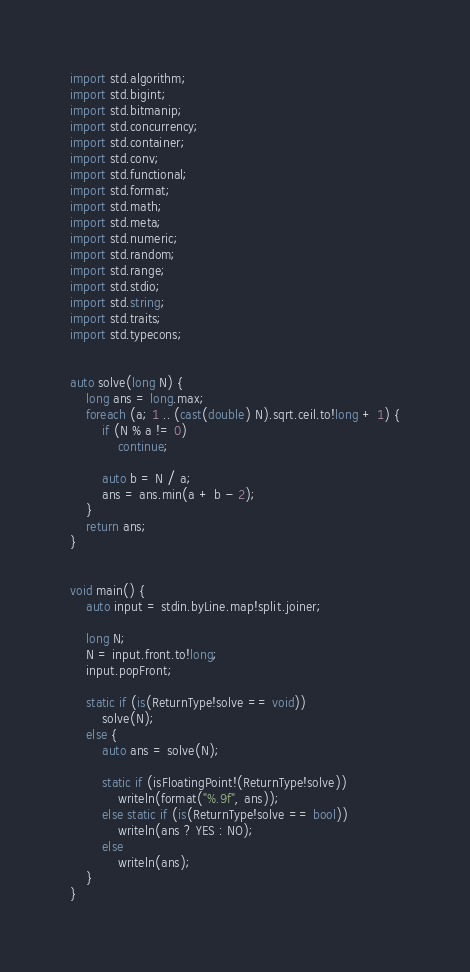Convert code to text. <code><loc_0><loc_0><loc_500><loc_500><_D_>import std.algorithm;
import std.bigint;
import std.bitmanip;
import std.concurrency;
import std.container;
import std.conv;
import std.functional;
import std.format;
import std.math;
import std.meta;
import std.numeric;
import std.random;
import std.range;
import std.stdio;
import std.string;
import std.traits;
import std.typecons;


auto solve(long N) {
    long ans = long.max;
    foreach (a; 1 .. (cast(double) N).sqrt.ceil.to!long + 1) {
        if (N % a != 0)
            continue;
        
        auto b = N / a;
        ans = ans.min(a + b - 2);
    }
    return ans;
}


void main() {
    auto input = stdin.byLine.map!split.joiner;

    long N;
    N = input.front.to!long;
    input.popFront;

    static if (is(ReturnType!solve == void))
        solve(N);
    else {
        auto ans = solve(N);

        static if (isFloatingPoint!(ReturnType!solve))
            writeln(format("%.9f", ans));
        else static if (is(ReturnType!solve == bool))
            writeln(ans ? YES : NO);
        else
            writeln(ans);
    }
}
</code> 